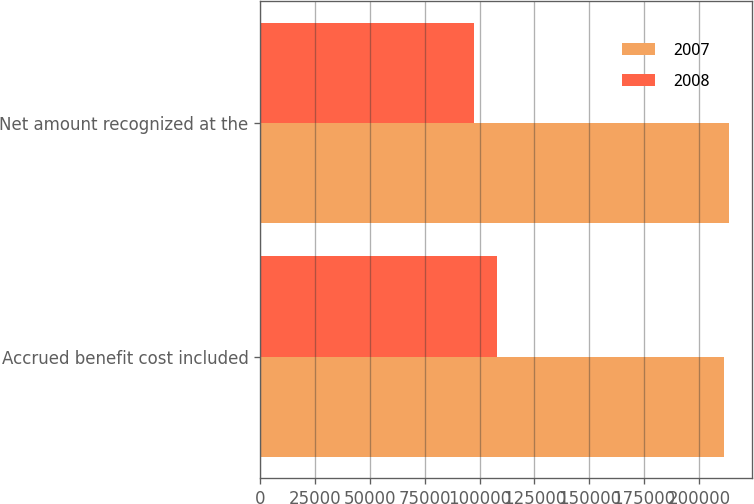Convert chart to OTSL. <chart><loc_0><loc_0><loc_500><loc_500><stacked_bar_chart><ecel><fcel>Accrued benefit cost included<fcel>Net amount recognized at the<nl><fcel>2007<fcel>211543<fcel>213466<nl><fcel>2008<fcel>108063<fcel>97280<nl></chart> 